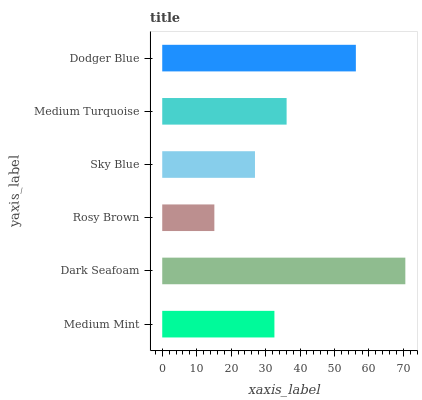Is Rosy Brown the minimum?
Answer yes or no. Yes. Is Dark Seafoam the maximum?
Answer yes or no. Yes. Is Dark Seafoam the minimum?
Answer yes or no. No. Is Rosy Brown the maximum?
Answer yes or no. No. Is Dark Seafoam greater than Rosy Brown?
Answer yes or no. Yes. Is Rosy Brown less than Dark Seafoam?
Answer yes or no. Yes. Is Rosy Brown greater than Dark Seafoam?
Answer yes or no. No. Is Dark Seafoam less than Rosy Brown?
Answer yes or no. No. Is Medium Turquoise the high median?
Answer yes or no. Yes. Is Medium Mint the low median?
Answer yes or no. Yes. Is Rosy Brown the high median?
Answer yes or no. No. Is Dodger Blue the low median?
Answer yes or no. No. 